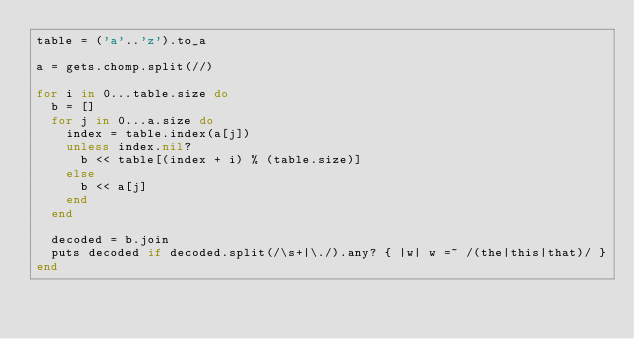<code> <loc_0><loc_0><loc_500><loc_500><_Ruby_>table = ('a'..'z').to_a

a = gets.chomp.split(//)

for i in 0...table.size do
  b = []
  for j in 0...a.size do
    index = table.index(a[j])
    unless index.nil?
      b << table[(index + i) % (table.size)]
    else
      b << a[j]
    end
  end

  decoded = b.join
  puts decoded if decoded.split(/\s+|\./).any? { |w| w =~ /(the|this|that)/ }
end</code> 